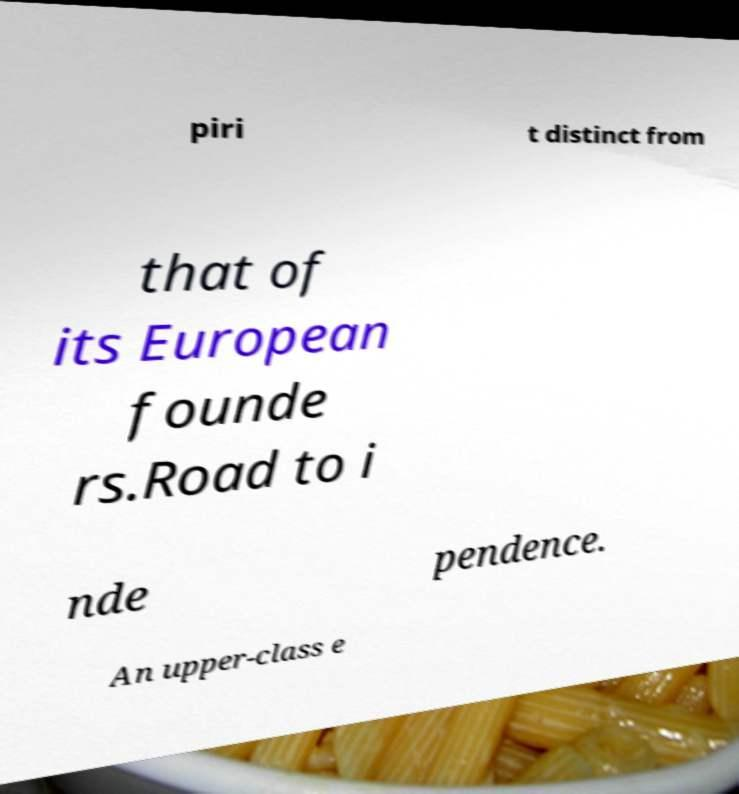Please read and relay the text visible in this image. What does it say? piri t distinct from that of its European founde rs.Road to i nde pendence. An upper-class e 